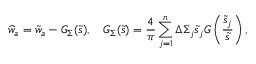Convert formula to latex. <formula><loc_0><loc_0><loc_500><loc_500>\widehat { w } _ { a } = \tilde { w } _ { a } - G _ { \Sigma } ( \tilde { s } ) , \quad G _ { \Sigma } ( \tilde { s } ) = \frac { 4 } { \pi } \sum _ { j = 1 } ^ { n } \Delta \Sigma _ { j } \tilde { s } _ { j } G \left ( \frac { \tilde { s } _ { j } } { \tilde { s } } \right ) ,</formula> 